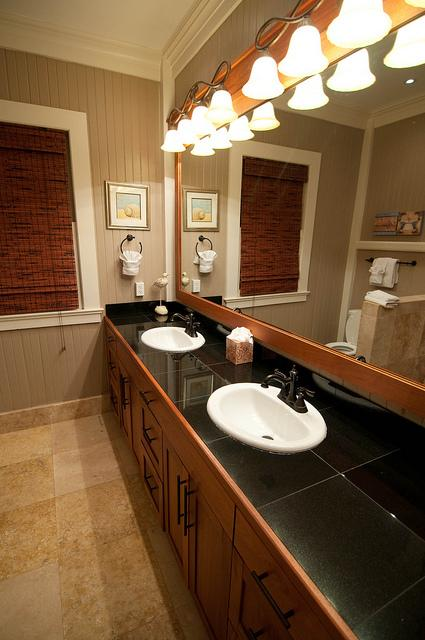What color are the sinks embedded in the black tile countertop?

Choices:
A) blue
B) green
C) white
D) pink white 